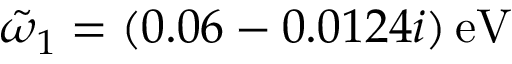<formula> <loc_0><loc_0><loc_500><loc_500>\tilde { \omega } _ { 1 } = ( 0 . 0 6 - 0 . 0 1 2 4 i ) \, e V</formula> 